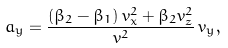<formula> <loc_0><loc_0><loc_500><loc_500>a _ { y } = \frac { \left ( \beta _ { 2 } - \beta _ { 1 } \right ) v _ { x } ^ { 2 } + \beta _ { 2 } v _ { z } ^ { 2 } } { v ^ { 2 } } \, v _ { y } ,</formula> 